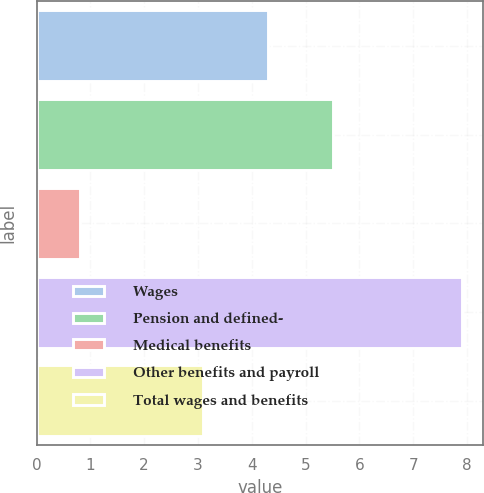<chart> <loc_0><loc_0><loc_500><loc_500><bar_chart><fcel>Wages<fcel>Pension and defined-<fcel>Medical benefits<fcel>Other benefits and payroll<fcel>Total wages and benefits<nl><fcel>4.3<fcel>5.5<fcel>0.8<fcel>7.9<fcel>3.1<nl></chart> 